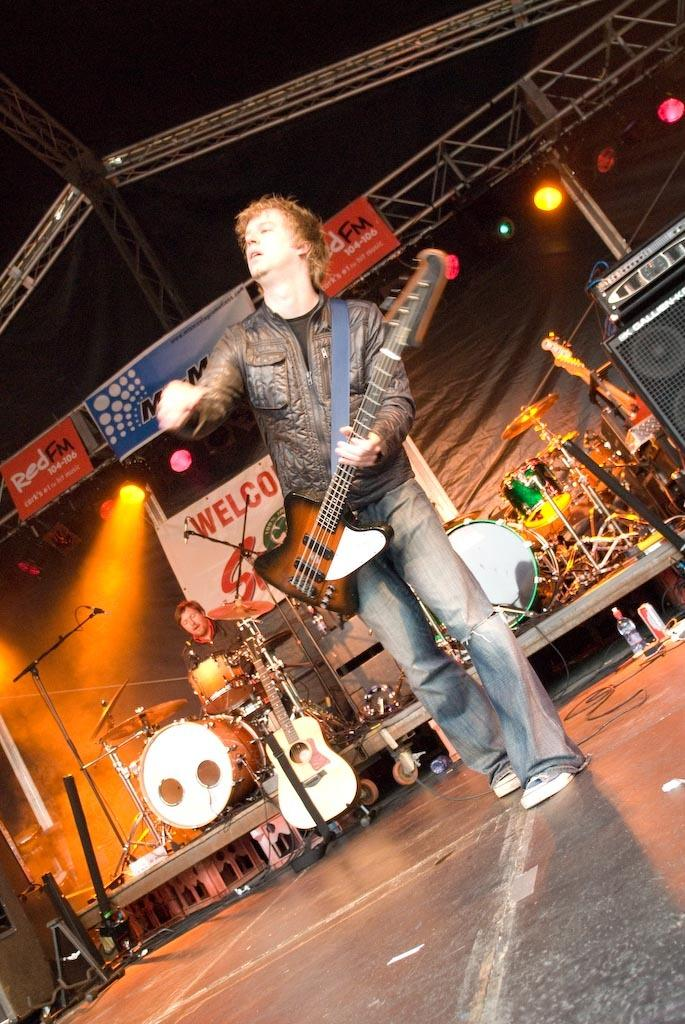What is the main activity of the person in the foreground of the image? The person in the foreground is standing and playing the guitar. What is the other person in the image doing? The other person is playing the drums in the background. What type of signage is present in the image? A hoarding is present in the image. What can be seen to enhance visibility in the image? Focus lights are visible in the image. What is used for amplifying sound in the image? A speaker is present in the image. What type of horse can be seen in the stomach of the person playing the guitar in the image? There is no horse or stomach visible in the image; it features a person playing the guitar and another playing the drums. 